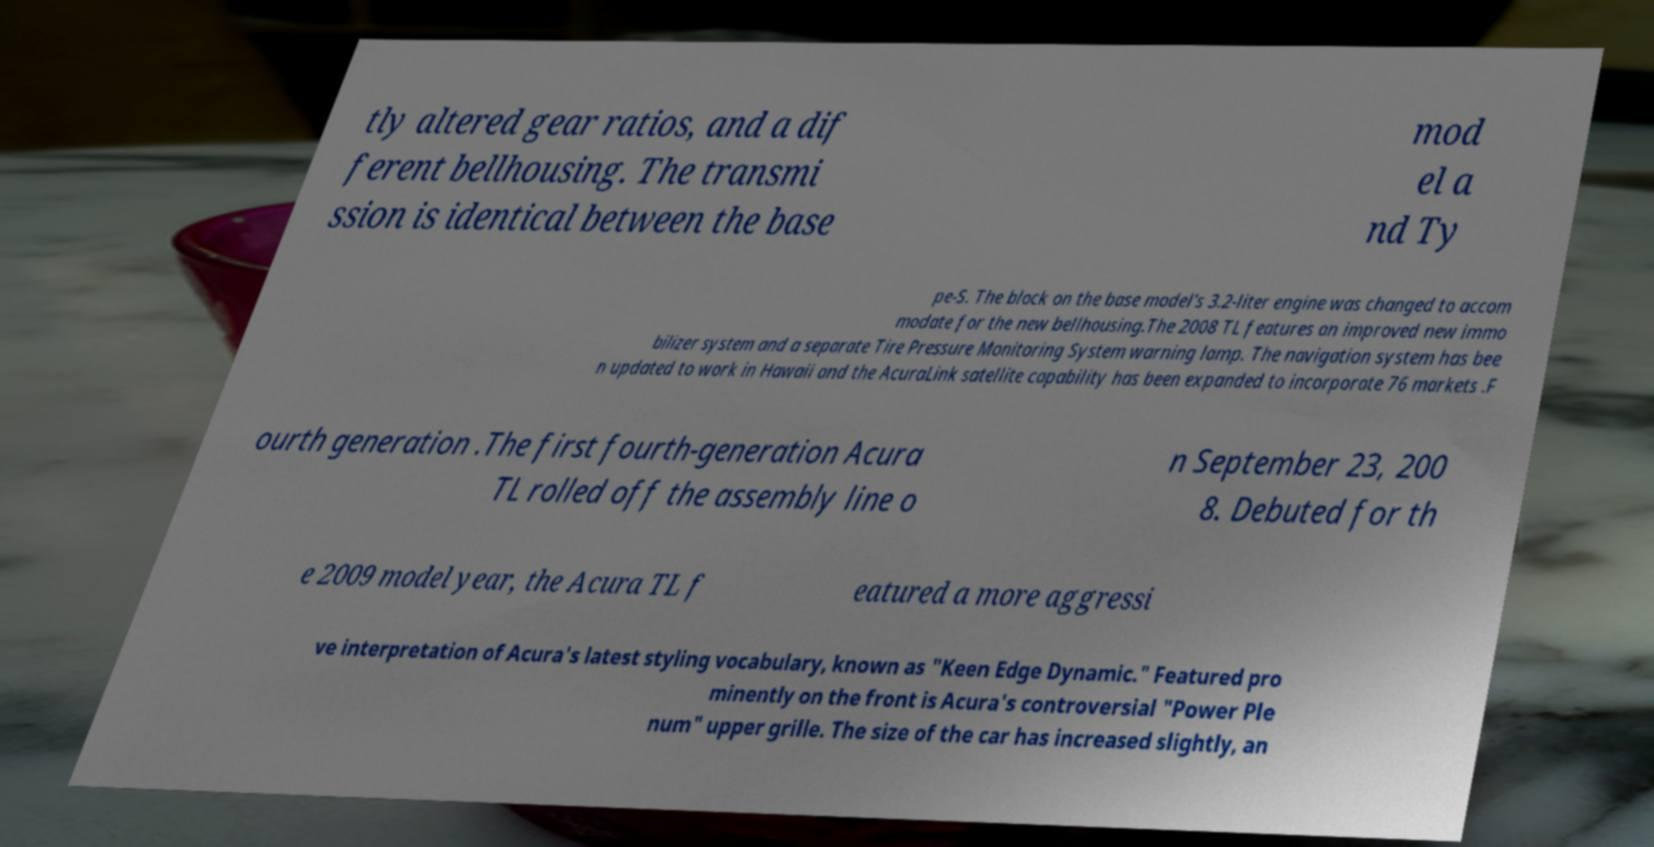Please identify and transcribe the text found in this image. tly altered gear ratios, and a dif ferent bellhousing. The transmi ssion is identical between the base mod el a nd Ty pe-S. The block on the base model's 3.2-liter engine was changed to accom modate for the new bellhousing.The 2008 TL features an improved new immo bilizer system and a separate Tire Pressure Monitoring System warning lamp. The navigation system has bee n updated to work in Hawaii and the AcuraLink satellite capability has been expanded to incorporate 76 markets .F ourth generation .The first fourth-generation Acura TL rolled off the assembly line o n September 23, 200 8. Debuted for th e 2009 model year, the Acura TL f eatured a more aggressi ve interpretation of Acura's latest styling vocabulary, known as "Keen Edge Dynamic." Featured pro minently on the front is Acura's controversial "Power Ple num" upper grille. The size of the car has increased slightly, an 